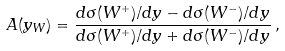Convert formula to latex. <formula><loc_0><loc_0><loc_500><loc_500>A ( y _ { W } ) = \frac { d \sigma ( W ^ { + } ) / d y - d \sigma ( W ^ { - } ) / d y } { d \sigma ( W ^ { + } ) / d y + d \sigma ( W ^ { - } ) / d y } \, ,</formula> 